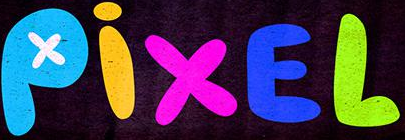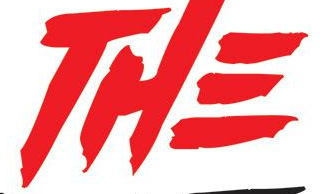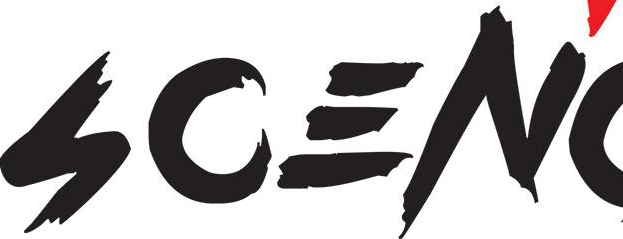What text is displayed in these images sequentially, separated by a semicolon? PixEL; THE; SCEN 